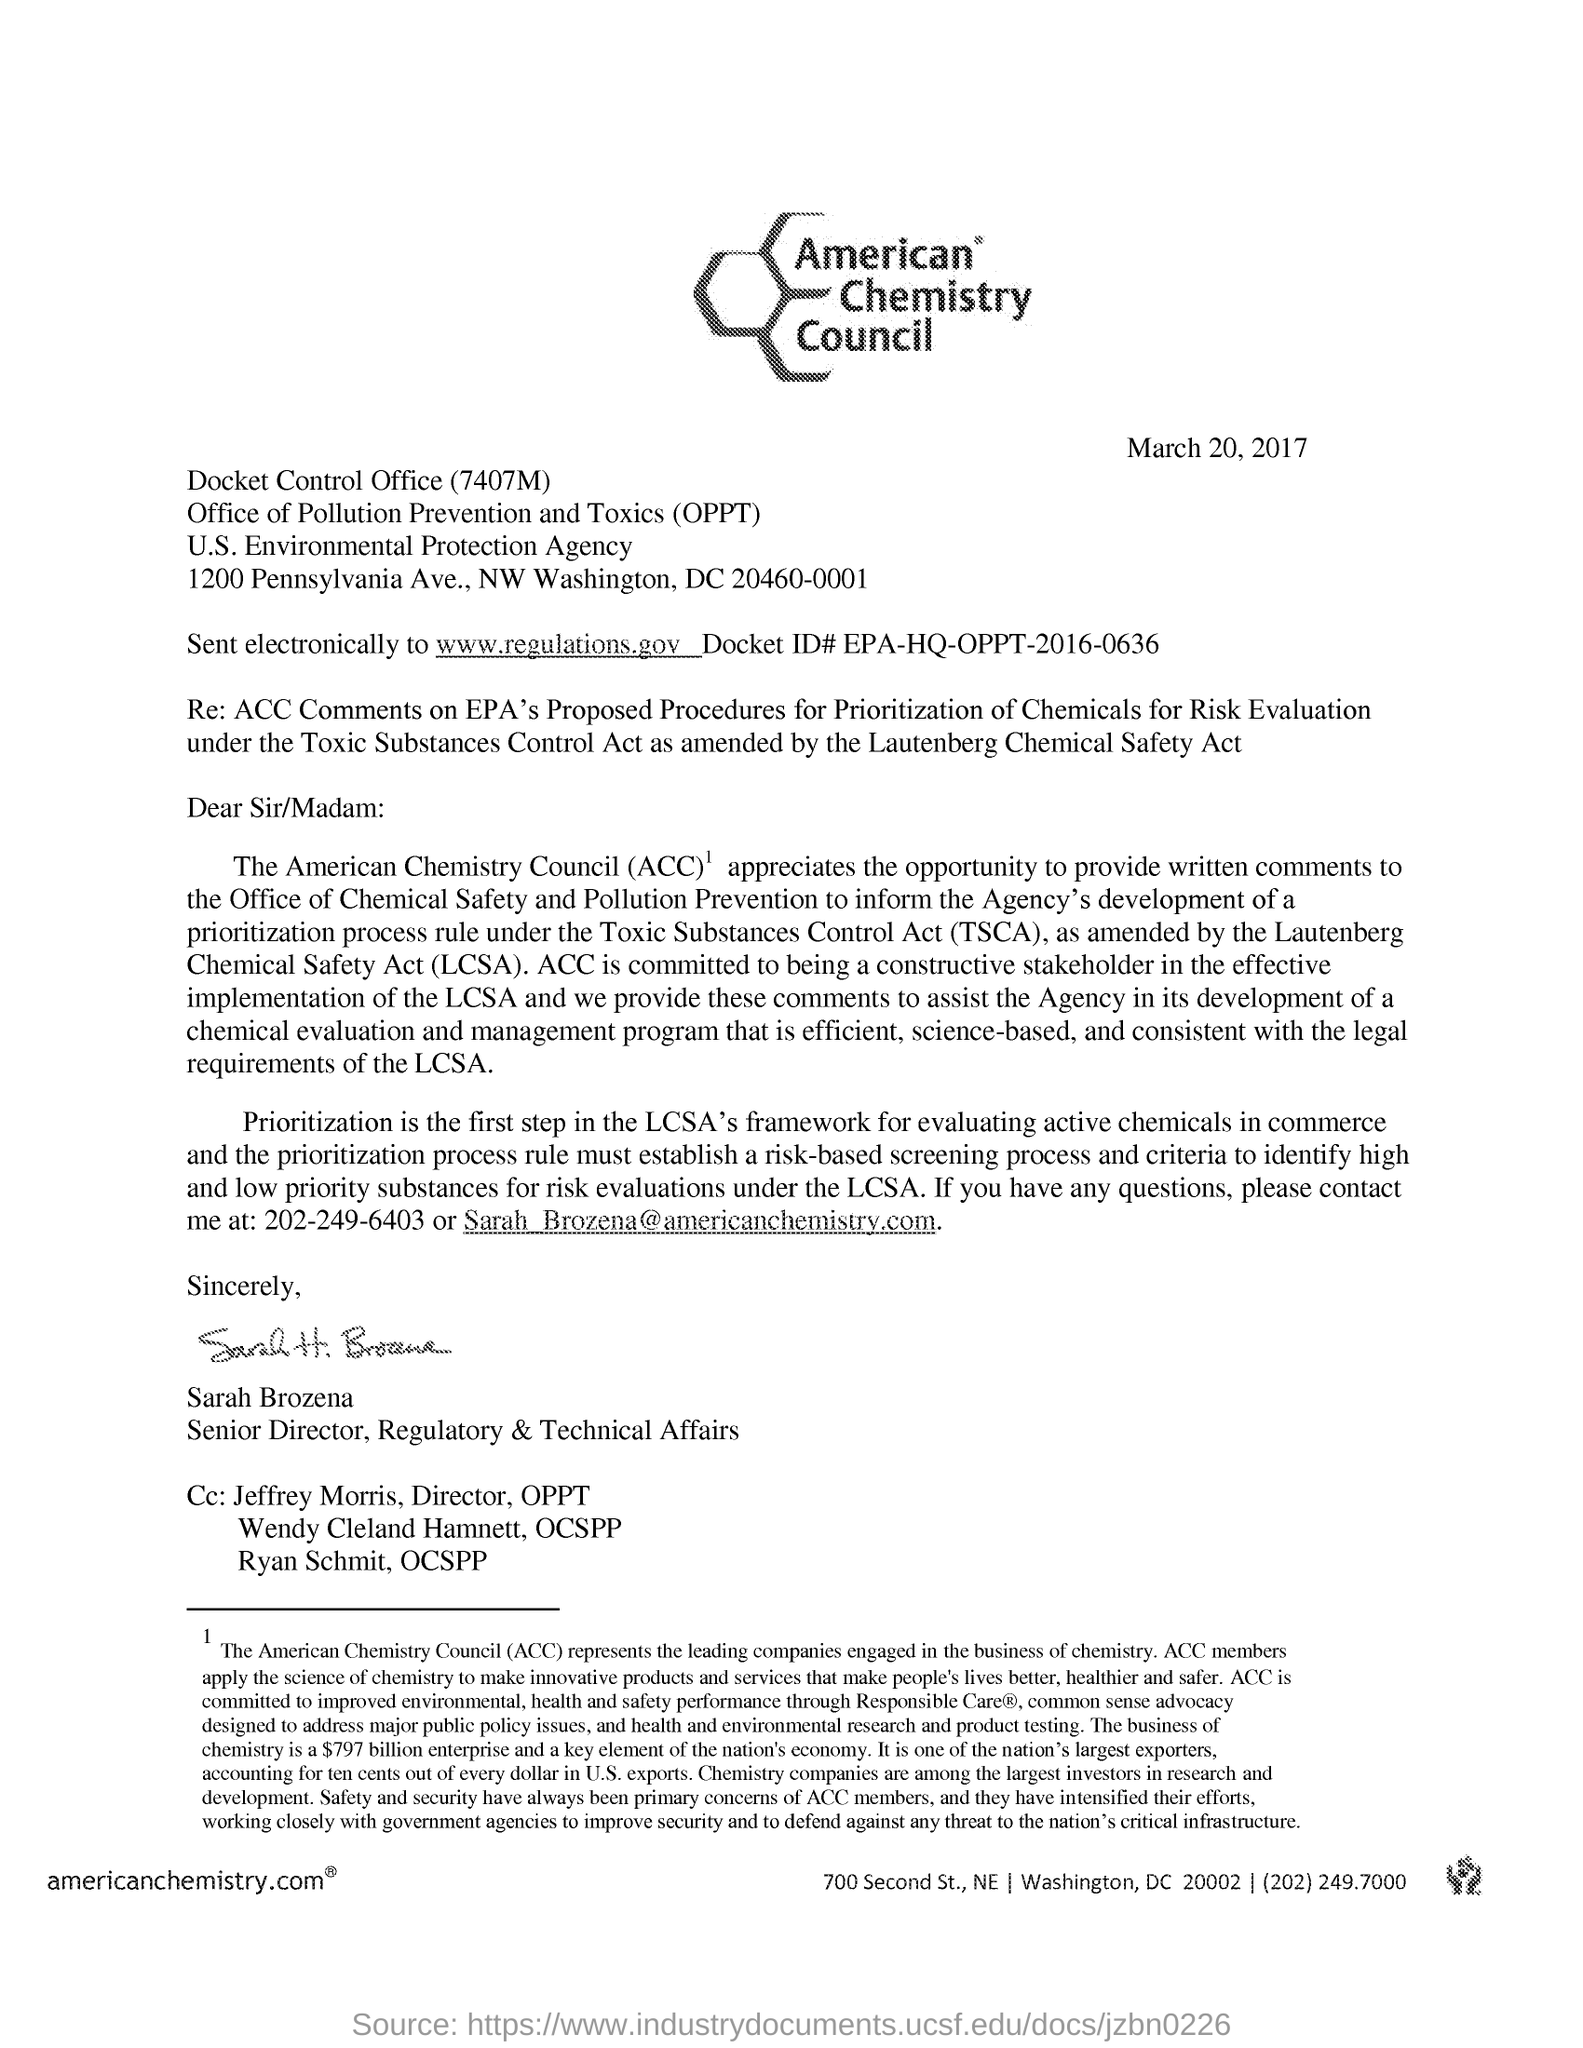Specify some key components in this picture. March 20, 2017, is the date mentioned. This letter is written by Sarah Brozena. The heading of the letter is "What is the heading of the letter? American Chemistry Council..". 